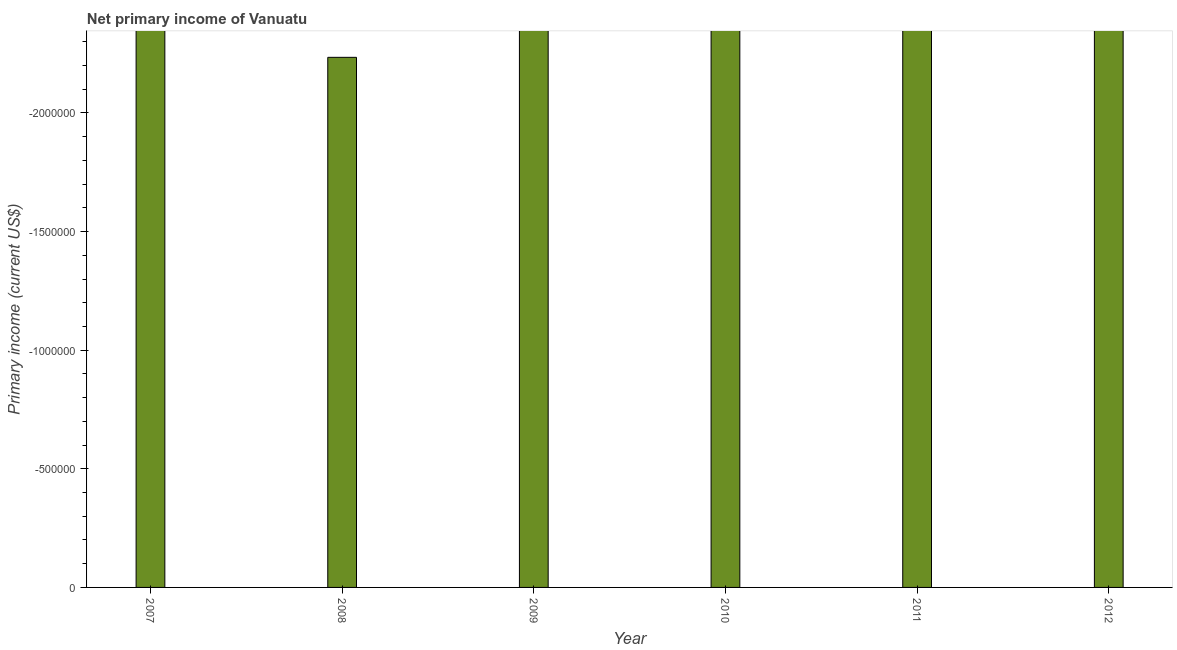Does the graph contain grids?
Offer a very short reply. No. What is the title of the graph?
Give a very brief answer. Net primary income of Vanuatu. What is the label or title of the X-axis?
Ensure brevity in your answer.  Year. What is the label or title of the Y-axis?
Your response must be concise. Primary income (current US$). What is the amount of primary income in 2008?
Give a very brief answer. 0. What is the median amount of primary income?
Your response must be concise. 0. In how many years, is the amount of primary income greater than the average amount of primary income taken over all years?
Offer a terse response. 0. How many years are there in the graph?
Make the answer very short. 6. What is the Primary income (current US$) in 2009?
Your answer should be very brief. 0. 